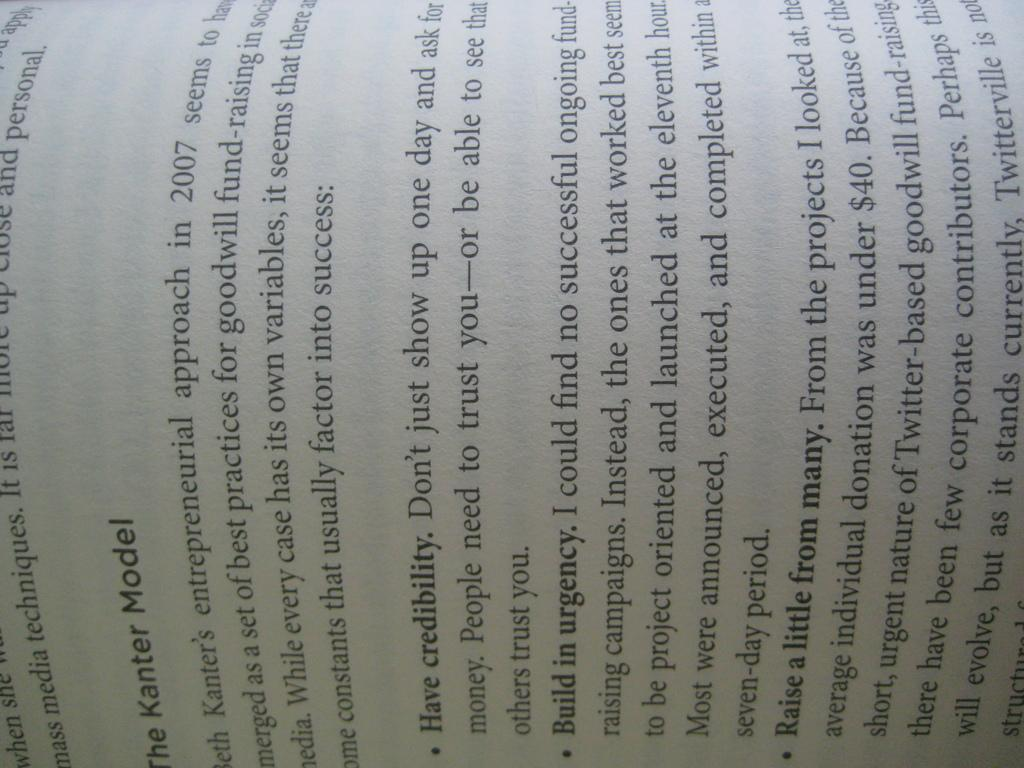<image>
Describe the image concisely. an open book page that says 'the kanter model' on it 